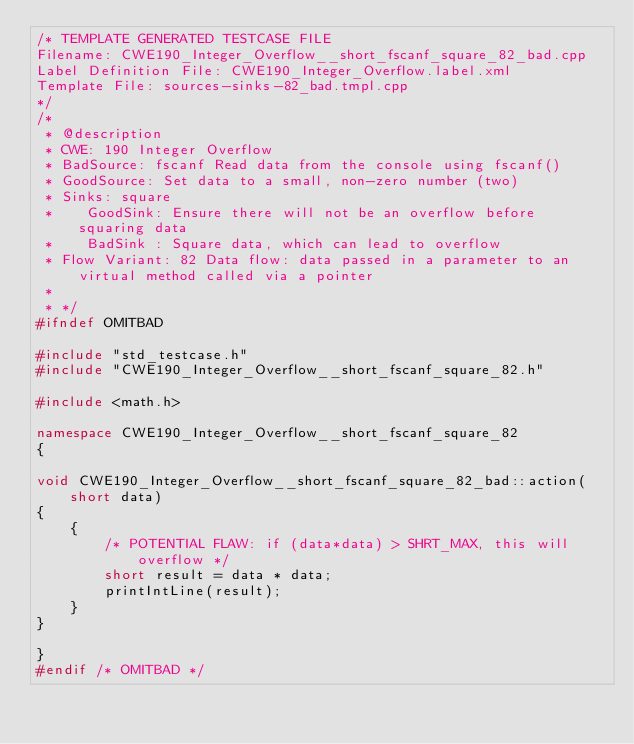Convert code to text. <code><loc_0><loc_0><loc_500><loc_500><_C++_>/* TEMPLATE GENERATED TESTCASE FILE
Filename: CWE190_Integer_Overflow__short_fscanf_square_82_bad.cpp
Label Definition File: CWE190_Integer_Overflow.label.xml
Template File: sources-sinks-82_bad.tmpl.cpp
*/
/*
 * @description
 * CWE: 190 Integer Overflow
 * BadSource: fscanf Read data from the console using fscanf()
 * GoodSource: Set data to a small, non-zero number (two)
 * Sinks: square
 *    GoodSink: Ensure there will not be an overflow before squaring data
 *    BadSink : Square data, which can lead to overflow
 * Flow Variant: 82 Data flow: data passed in a parameter to an virtual method called via a pointer
 *
 * */
#ifndef OMITBAD

#include "std_testcase.h"
#include "CWE190_Integer_Overflow__short_fscanf_square_82.h"

#include <math.h>

namespace CWE190_Integer_Overflow__short_fscanf_square_82
{

void CWE190_Integer_Overflow__short_fscanf_square_82_bad::action(short data)
{
    {
        /* POTENTIAL FLAW: if (data*data) > SHRT_MAX, this will overflow */
        short result = data * data;
        printIntLine(result);
    }
}

}
#endif /* OMITBAD */
</code> 